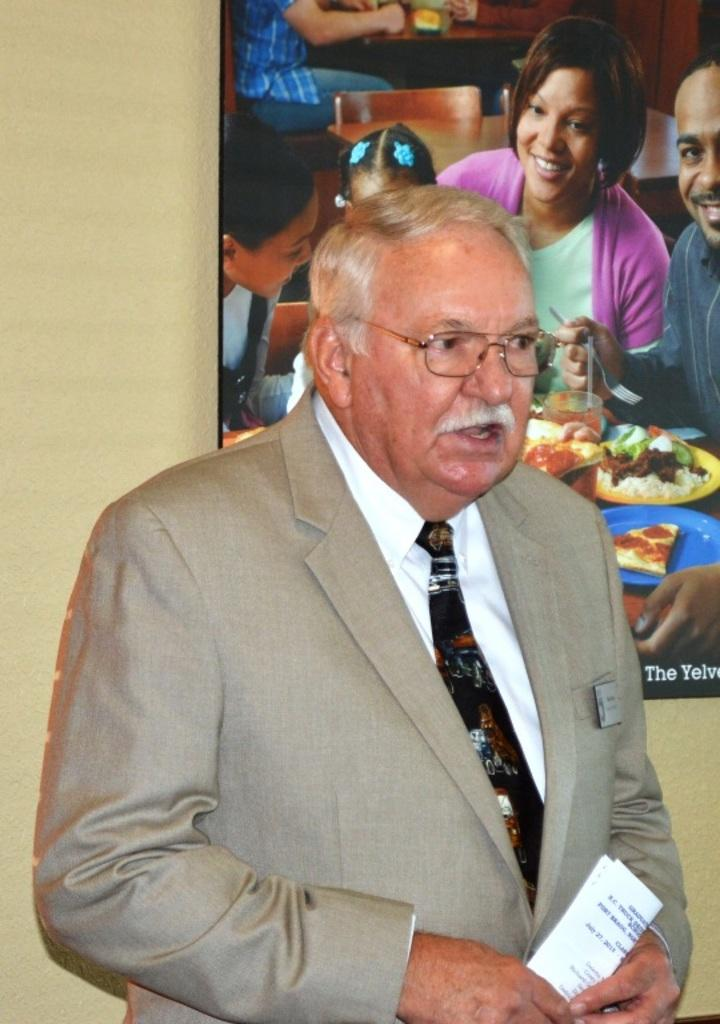What is the person in the image holding? The person is holding a paper. What can be seen in the background of the image? There is a wall, a photo frame, people, chairs, food, and some objects visible in the background of the image. Can you describe the setting where the person is located? The person is in a room with a wall, a photo frame, chairs, and some objects. There are also people and food visible in the background. How many bikes are parked in the room in the image? There are no bikes present in the image. What type of punishment is being administered to the person in the image? There is no punishment being administered to the person in the image; they are simply holding a paper. 